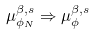Convert formula to latex. <formula><loc_0><loc_0><loc_500><loc_500>\mu _ { \phi _ { N } } ^ { \beta , s } \Rightarrow \mu _ { \phi } ^ { \beta , s } \,</formula> 